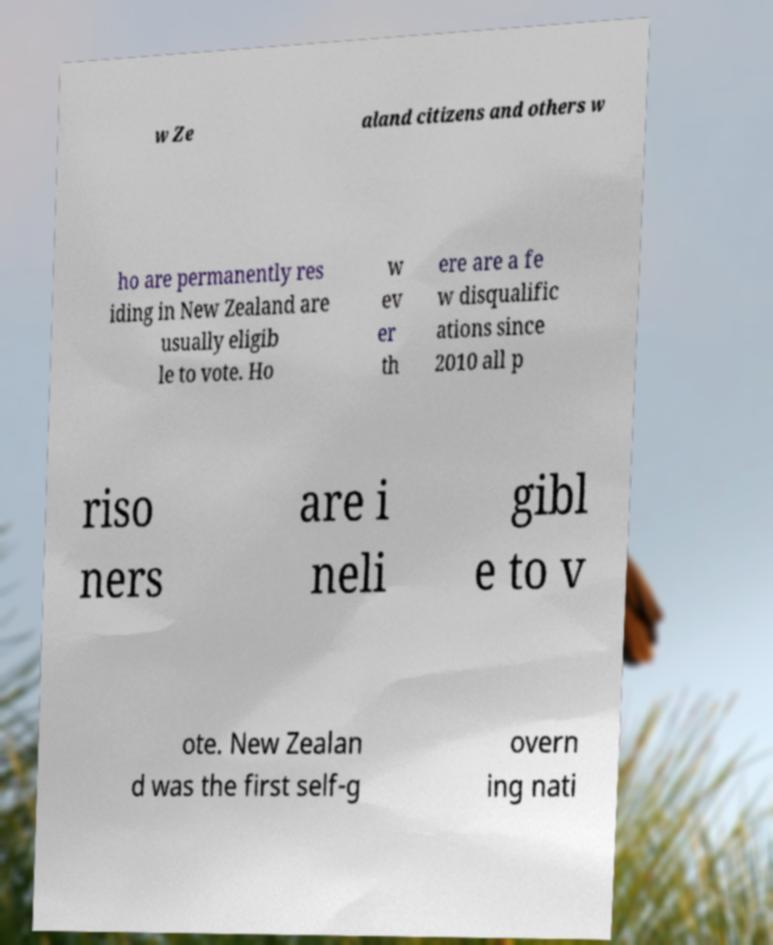There's text embedded in this image that I need extracted. Can you transcribe it verbatim? w Ze aland citizens and others w ho are permanently res iding in New Zealand are usually eligib le to vote. Ho w ev er th ere are a fe w disqualific ations since 2010 all p riso ners are i neli gibl e to v ote. New Zealan d was the first self-g overn ing nati 